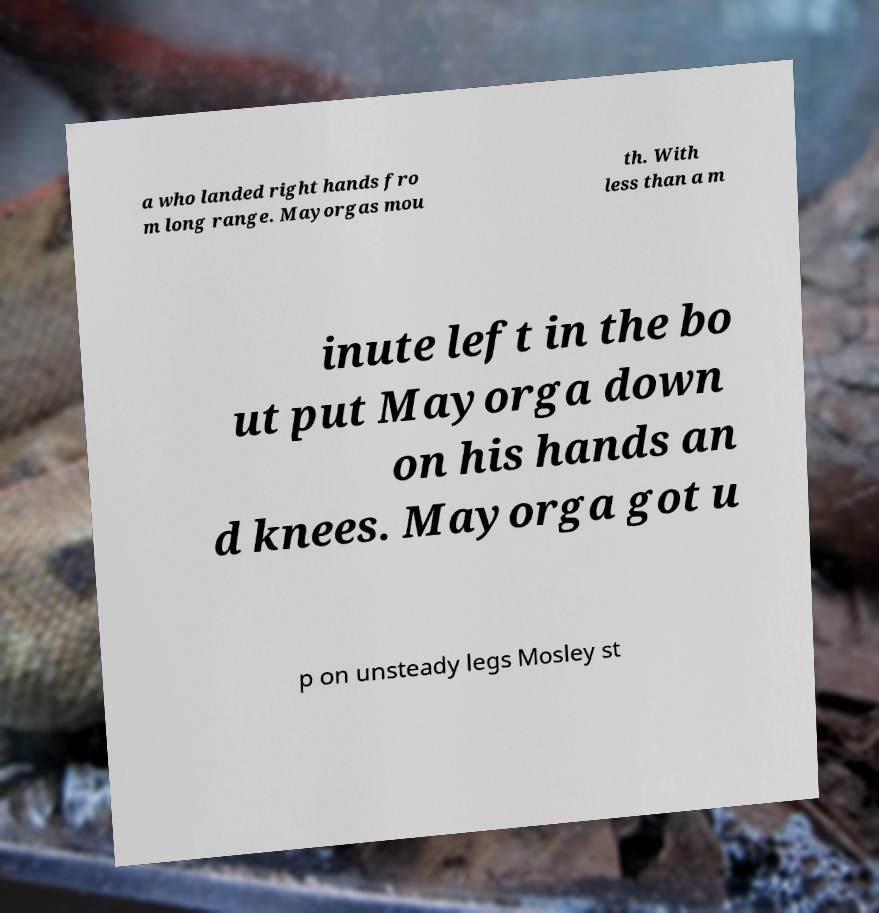Please read and relay the text visible in this image. What does it say? a who landed right hands fro m long range. Mayorgas mou th. With less than a m inute left in the bo ut put Mayorga down on his hands an d knees. Mayorga got u p on unsteady legs Mosley st 